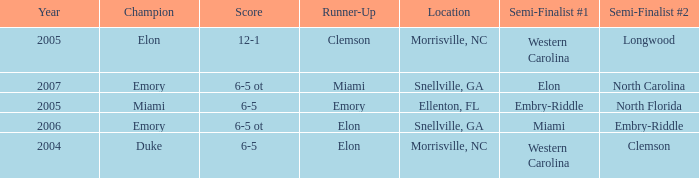Help me parse the entirety of this table. {'header': ['Year', 'Champion', 'Score', 'Runner-Up', 'Location', 'Semi-Finalist #1', 'Semi-Finalist #2'], 'rows': [['2005', 'Elon', '12-1', 'Clemson', 'Morrisville, NC', 'Western Carolina', 'Longwood'], ['2007', 'Emory', '6-5 ot', 'Miami', 'Snellville, GA', 'Elon', 'North Carolina'], ['2005', 'Miami', '6-5', 'Emory', 'Ellenton, FL', 'Embry-Riddle', 'North Florida'], ['2006', 'Emory', '6-5 ot', 'Elon', 'Snellville, GA', 'Miami', 'Embry-Riddle'], ['2004', 'Duke', '6-5', 'Elon', 'Morrisville, NC', 'Western Carolina', 'Clemson']]} When Embry-Riddle made it to the first semi finalist slot, list all the runners up. Emory. 